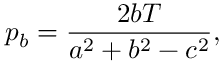<formula> <loc_0><loc_0><loc_500><loc_500>p _ { b } = { \frac { 2 b T } { a ^ { 2 } + b ^ { 2 } - c ^ { 2 } } } ,</formula> 